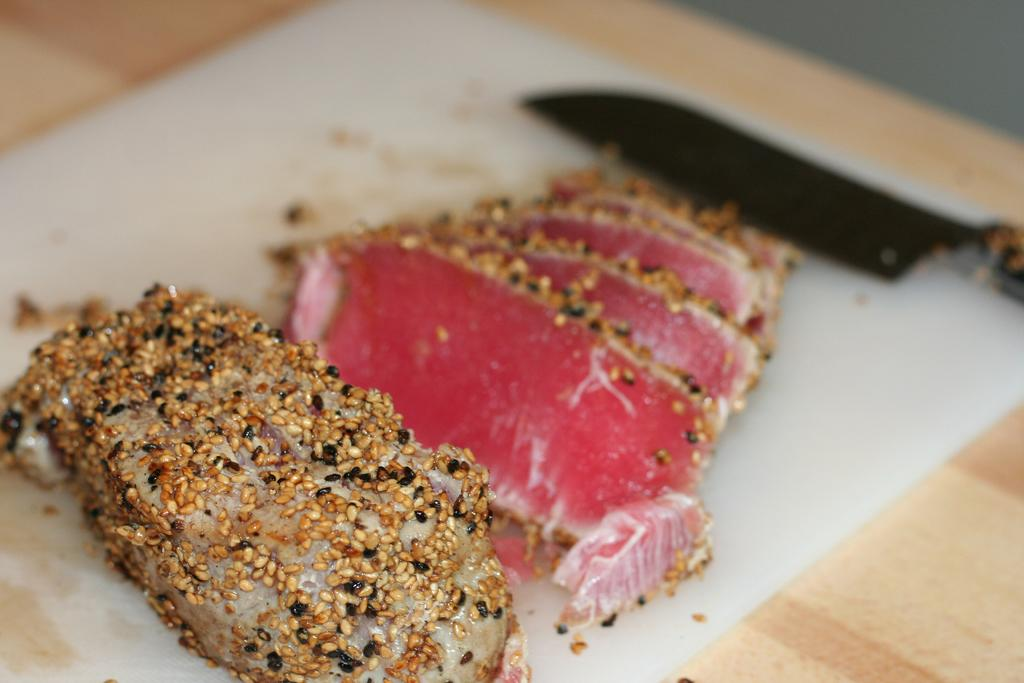What type of food item is visible in the image? There is a food item in the image, specifically meat. Where is the meat located in the image? The meat is on a table. What utensil is present near the meat on the table? There is a knife beside the meat on the table. What type of pipe is visible in the image? There is no pipe present in the image. How does the meat feel about being on the table? The meat is an inanimate object and does not have feelings. 